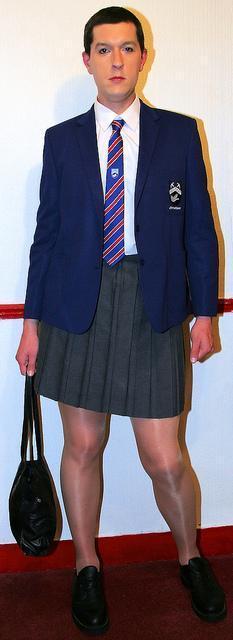How many of the birds eyes can you see?
Give a very brief answer. 0. 